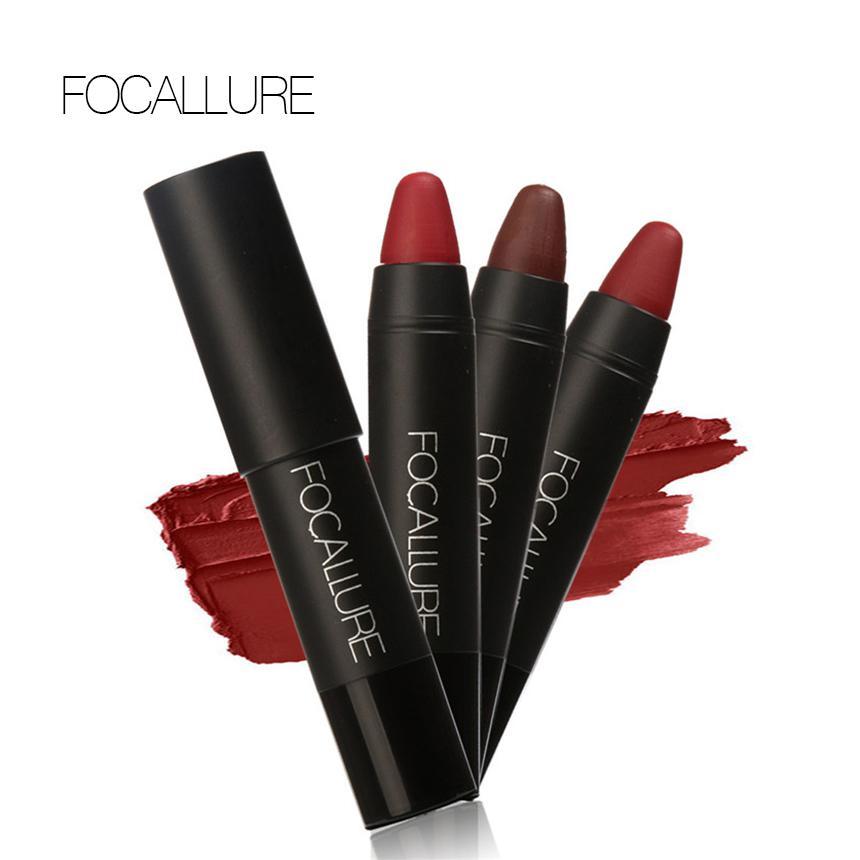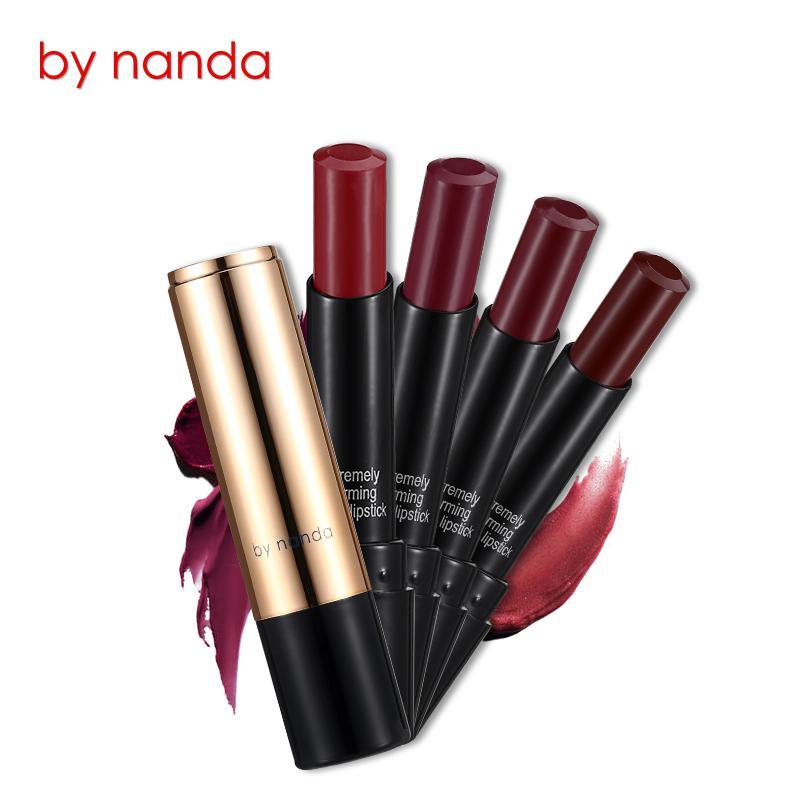The first image is the image on the left, the second image is the image on the right. Examine the images to the left and right. Is the description "The left image shows exactly one lipstick next to its cap." accurate? Answer yes or no. No. The first image is the image on the left, the second image is the image on the right. Evaluate the accuracy of this statement regarding the images: "The left image shows one lipstick next to its cap.". Is it true? Answer yes or no. No. 